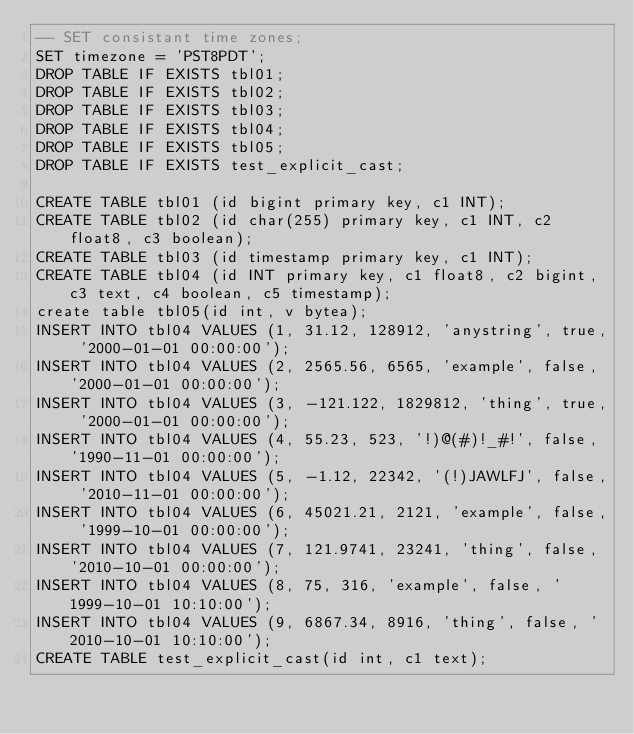Convert code to text. <code><loc_0><loc_0><loc_500><loc_500><_SQL_>-- SET consistant time zones;
SET timezone = 'PST8PDT';
DROP TABLE IF EXISTS tbl01;
DROP TABLE IF EXISTS tbl02;
DROP TABLE IF EXISTS tbl03;
DROP TABLE IF EXISTS tbl04;
DROP TABLE IF EXISTS tbl05;
DROP TABLE IF EXISTS test_explicit_cast;

CREATE TABLE tbl01 (id bigint primary key, c1 INT);
CREATE TABLE tbl02 (id char(255) primary key, c1 INT, c2 float8, c3 boolean);
CREATE TABLE tbl03 (id timestamp primary key, c1 INT);
CREATE TABLE tbl04 (id INT primary key, c1 float8, c2 bigint, c3 text, c4 boolean, c5 timestamp);
create table tbl05(id int, v bytea);
INSERT INTO tbl04 VALUES (1, 31.12, 128912, 'anystring', true, '2000-01-01 00:00:00');
INSERT INTO tbl04 VALUES (2, 2565.56, 6565, 'example', false, '2000-01-01 00:00:00');
INSERT INTO tbl04 VALUES (3, -121.122, 1829812, 'thing', true, '2000-01-01 00:00:00');
INSERT INTO tbl04 VALUES (4, 55.23, 523, '!)@(#)!_#!', false, '1990-11-01 00:00:00');
INSERT INTO tbl04 VALUES (5, -1.12, 22342, '(!)JAWLFJ', false, '2010-11-01 00:00:00');
INSERT INTO tbl04 VALUES (6, 45021.21, 2121, 'example', false, '1999-10-01 00:00:00');
INSERT INTO tbl04 VALUES (7, 121.9741, 23241, 'thing', false, '2010-10-01 00:00:00');
INSERT INTO tbl04 VALUES (8, 75, 316, 'example', false, '1999-10-01 10:10:00');
INSERT INTO tbl04 VALUES (9, 6867.34, 8916, 'thing', false, '2010-10-01 10:10:00');
CREATE TABLE test_explicit_cast(id int, c1 text);
</code> 